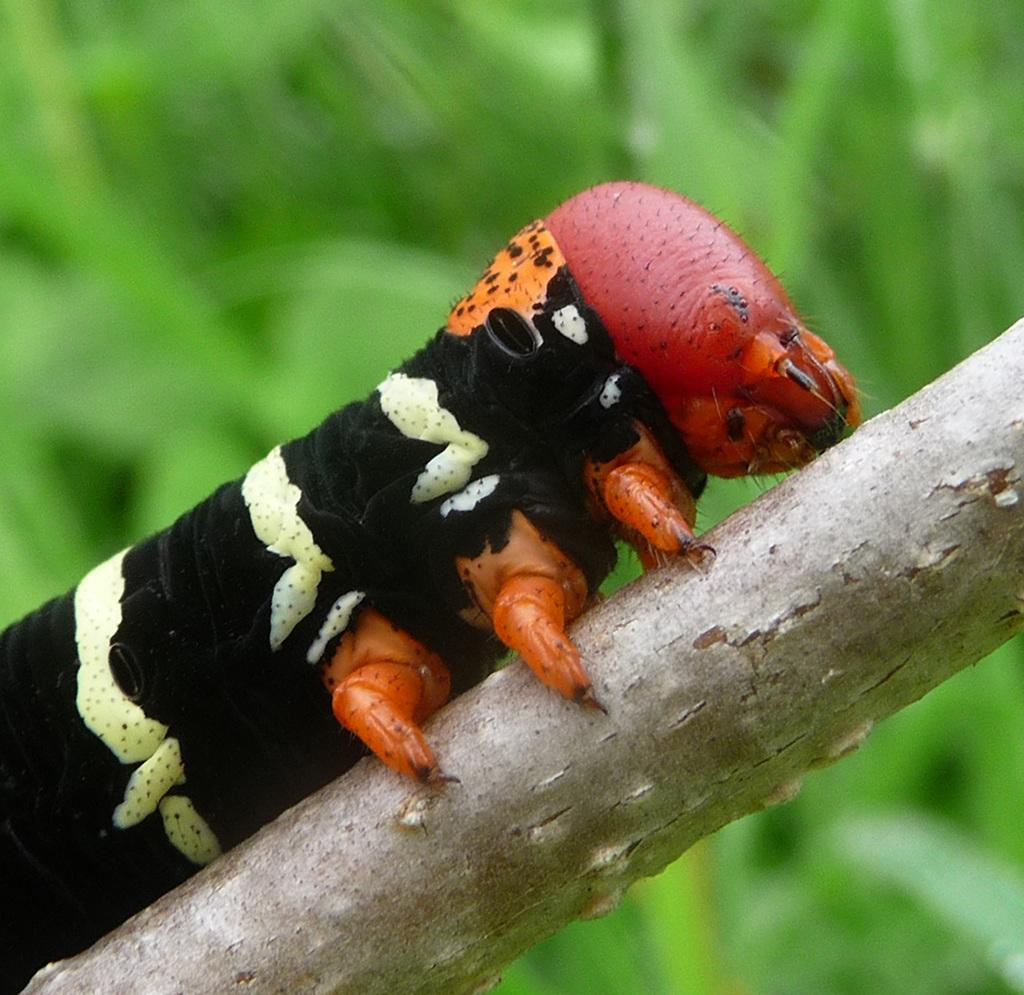What is present on the tree in the image? There is a worm on a tree in the image. What can be seen in the background of the image? There are plants visible in the background of the image. Can you touch the chair in the image? There is no chair present in the image. What type of nut is being cracked by the worm in the image? The image does not show the worm cracking a nut, nor is there any nut present. 